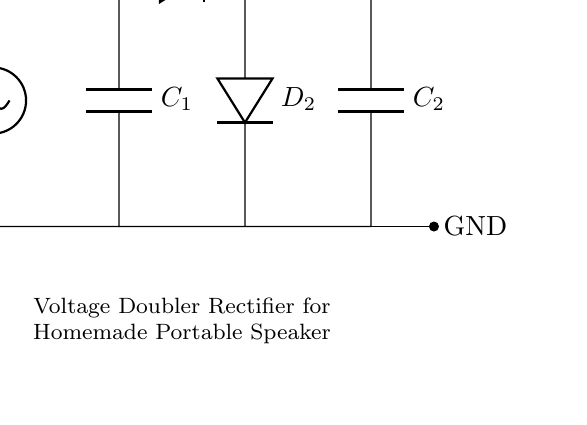What type of circuit is shown? The circuit is a voltage doubler rectifier, which is indicated by the arrangement of the diodes and capacitors designed to increase the output voltage.
Answer: voltage doubler rectifier How many diodes are used in the circuit? There are two diodes present in the circuit; they are labeled D1 and D2.
Answer: two What is the input voltage labeled in the circuit? The input voltage, labeled as V_in, is shown at the left side of the diagram, representing the incoming voltage supply.
Answer: V_in What is the output voltage relative to the input? The output voltage is stated as V_out, which is approximately double the input voltage (2V_in). This is indicated on the right side of the circuit.
Answer: approximately 2V_in What components are used to store charge in this circuit? The components responsible for storing charge in the circuit are the capacitors, labeled C1 and C2, which smooth the output voltage after rectification.
Answer: C1 and C2 Why does this circuit double the voltage? The circuit doubles the voltage through a specific arrangement of two diodes and two capacitors, where the diodes allow current to flow in a manner that adds the voltages across the capacitors sequentially during the rectification process.
Answer: By arranging diodes and capacitors to add voltages What is the purpose of the capacitors in this circuit? The capacitors serve to smooth the output voltage by storing charge and releasing it when needed, which stabilizes the voltage supplied to the load in the portable speaker system.
Answer: To smooth the output voltage 